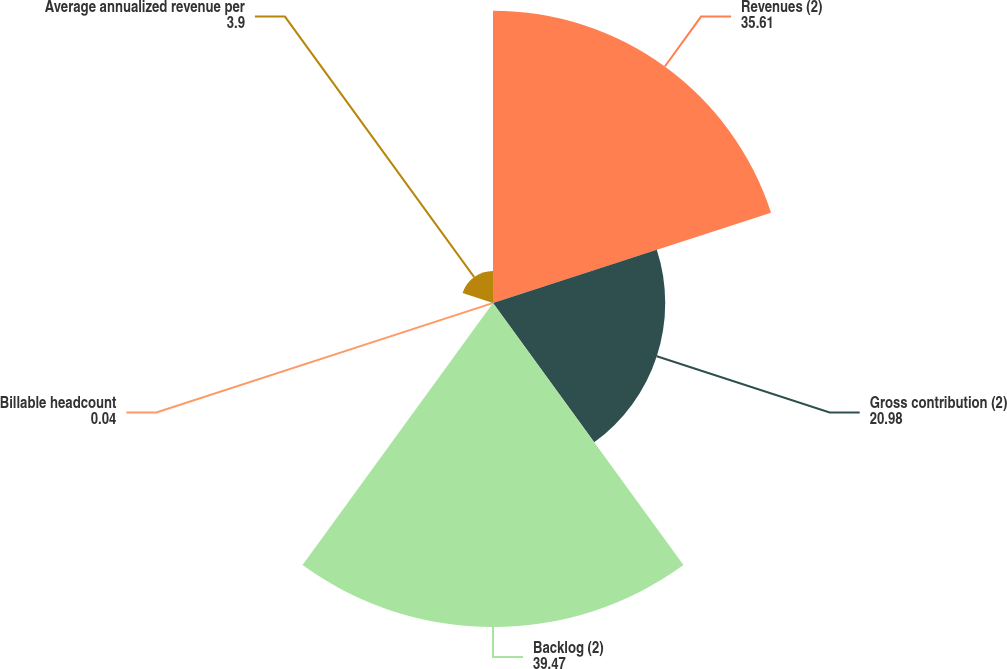Convert chart. <chart><loc_0><loc_0><loc_500><loc_500><pie_chart><fcel>Revenues (2)<fcel>Gross contribution (2)<fcel>Backlog (2)<fcel>Billable headcount<fcel>Average annualized revenue per<nl><fcel>35.61%<fcel>20.98%<fcel>39.47%<fcel>0.04%<fcel>3.9%<nl></chart> 